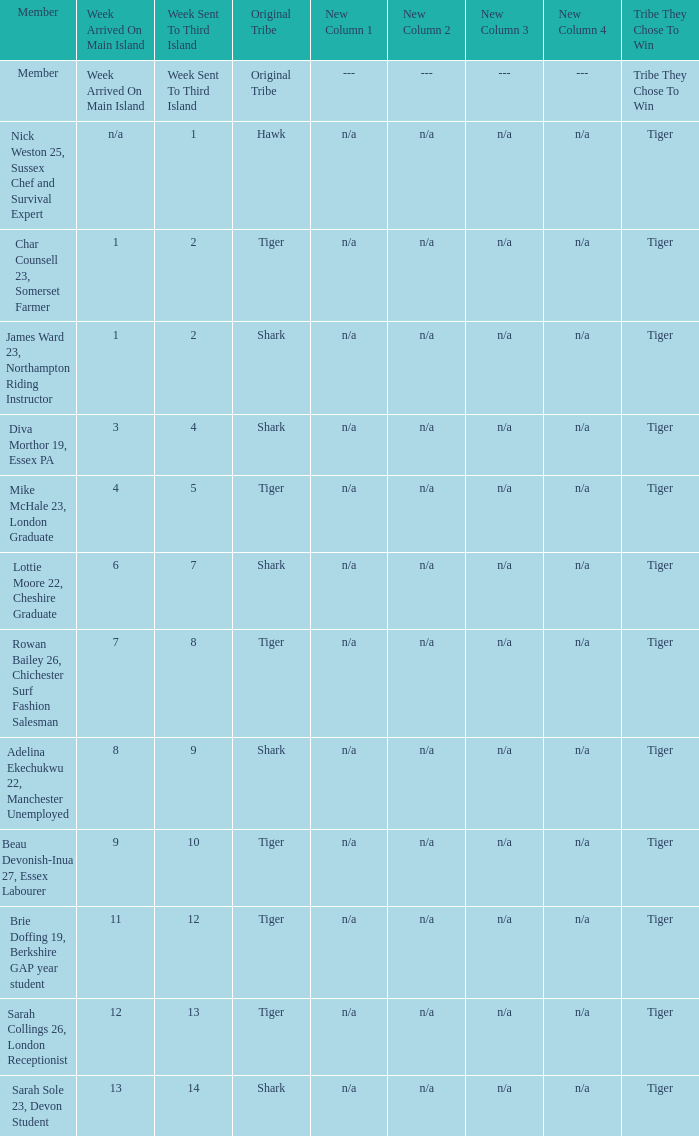How many members arrived on the main island in week 4? 1.0. Can you parse all the data within this table? {'header': ['Member', 'Week Arrived On Main Island', 'Week Sent To Third Island', 'Original Tribe', 'New Column 1', 'New Column 2', 'New Column 3', 'New Column 4', 'Tribe They Chose To Win'], 'rows': [['Member', 'Week Arrived On Main Island', 'Week Sent To Third Island', 'Original Tribe', '---', '---', '---', '---', 'Tribe They Chose To Win'], ['Nick Weston 25, Sussex Chef and Survival Expert', 'n/a', '1', 'Hawk', 'n/a', 'n/a', 'n/a', 'n/a', 'Tiger'], ['Char Counsell 23, Somerset Farmer', '1', '2', 'Tiger', 'n/a', 'n/a', 'n/a', 'n/a', 'Tiger'], ['James Ward 23, Northampton Riding Instructor', '1', '2', 'Shark', 'n/a', 'n/a', 'n/a', 'n/a', 'Tiger'], ['Diva Morthor 19, Essex PA', '3', '4', 'Shark', 'n/a', 'n/a', 'n/a', 'n/a', 'Tiger'], ['Mike McHale 23, London Graduate', '4', '5', 'Tiger', 'n/a', 'n/a', 'n/a', 'n/a', 'Tiger'], ['Lottie Moore 22, Cheshire Graduate', '6', '7', 'Shark', 'n/a', 'n/a', 'n/a', 'n/a', 'Tiger'], ['Rowan Bailey 26, Chichester Surf Fashion Salesman', '7', '8', 'Tiger', 'n/a', 'n/a', 'n/a', 'n/a', 'Tiger'], ['Adelina Ekechukwu 22, Manchester Unemployed', '8', '9', 'Shark', 'n/a', 'n/a', 'n/a', 'n/a', 'Tiger'], ['Beau Devonish-Inua 27, Essex Labourer', '9', '10', 'Tiger', 'n/a', 'n/a', 'n/a', 'n/a', 'Tiger'], ['Brie Doffing 19, Berkshire GAP year student', '11', '12', 'Tiger', 'n/a', 'n/a', 'n/a', 'n/a', 'Tiger'], ['Sarah Collings 26, London Receptionist', '12', '13', 'Tiger', 'n/a', 'n/a', 'n/a', 'n/a', 'Tiger'], ['Sarah Sole 23, Devon Student', '13', '14', 'Shark', 'n/a', 'n/a', 'n/a', 'n/a', 'Tiger']]} 